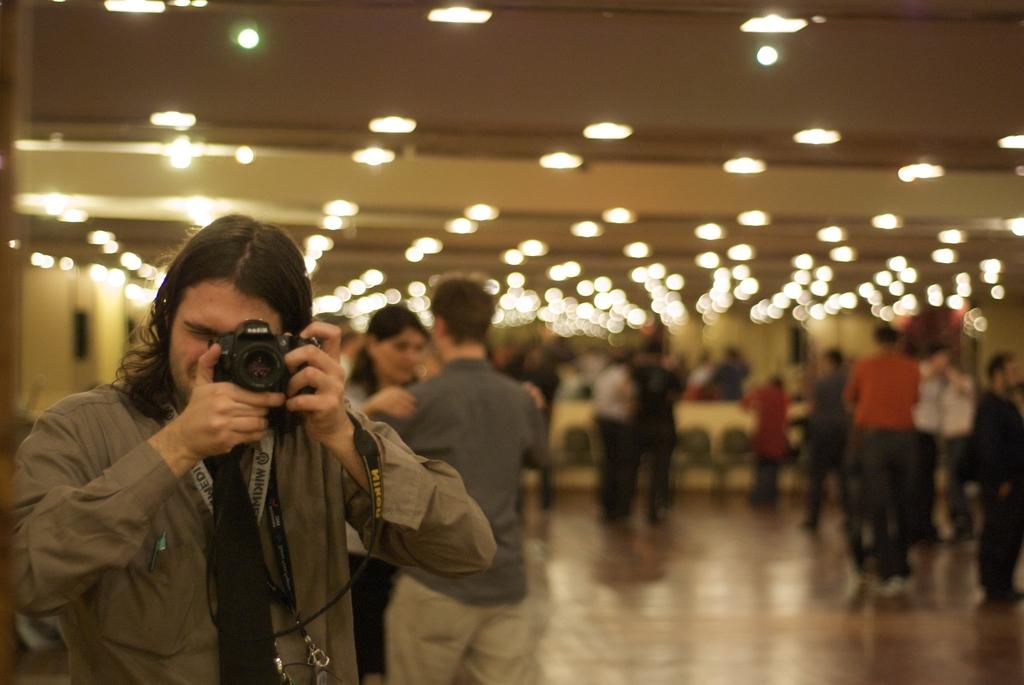What can be seen in the image that provides illumination? There are lights in the image. What is the presence of people in the image suggestive of? There are people standing in the image, which suggests that they are observing or participating in an event or activity. What is the man in the image holding? A man is holding a camera in the image, which suggests that he may be taking photographs. What type of friction can be observed between the people in the image? There is no indication of friction between the people in the image; they are simply standing together. How does the roof contribute to the overall composition of the image? There is no mention of a roof in the image, so it cannot be considered in the composition. 